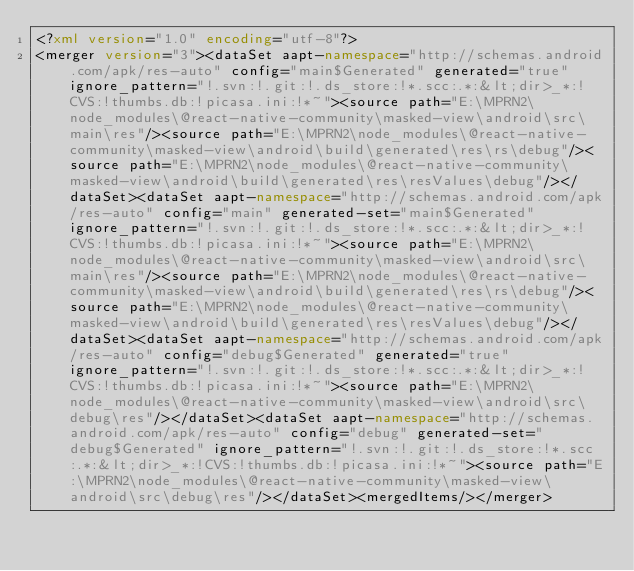<code> <loc_0><loc_0><loc_500><loc_500><_XML_><?xml version="1.0" encoding="utf-8"?>
<merger version="3"><dataSet aapt-namespace="http://schemas.android.com/apk/res-auto" config="main$Generated" generated="true" ignore_pattern="!.svn:!.git:!.ds_store:!*.scc:.*:&lt;dir>_*:!CVS:!thumbs.db:!picasa.ini:!*~"><source path="E:\MPRN2\node_modules\@react-native-community\masked-view\android\src\main\res"/><source path="E:\MPRN2\node_modules\@react-native-community\masked-view\android\build\generated\res\rs\debug"/><source path="E:\MPRN2\node_modules\@react-native-community\masked-view\android\build\generated\res\resValues\debug"/></dataSet><dataSet aapt-namespace="http://schemas.android.com/apk/res-auto" config="main" generated-set="main$Generated" ignore_pattern="!.svn:!.git:!.ds_store:!*.scc:.*:&lt;dir>_*:!CVS:!thumbs.db:!picasa.ini:!*~"><source path="E:\MPRN2\node_modules\@react-native-community\masked-view\android\src\main\res"/><source path="E:\MPRN2\node_modules\@react-native-community\masked-view\android\build\generated\res\rs\debug"/><source path="E:\MPRN2\node_modules\@react-native-community\masked-view\android\build\generated\res\resValues\debug"/></dataSet><dataSet aapt-namespace="http://schemas.android.com/apk/res-auto" config="debug$Generated" generated="true" ignore_pattern="!.svn:!.git:!.ds_store:!*.scc:.*:&lt;dir>_*:!CVS:!thumbs.db:!picasa.ini:!*~"><source path="E:\MPRN2\node_modules\@react-native-community\masked-view\android\src\debug\res"/></dataSet><dataSet aapt-namespace="http://schemas.android.com/apk/res-auto" config="debug" generated-set="debug$Generated" ignore_pattern="!.svn:!.git:!.ds_store:!*.scc:.*:&lt;dir>_*:!CVS:!thumbs.db:!picasa.ini:!*~"><source path="E:\MPRN2\node_modules\@react-native-community\masked-view\android\src\debug\res"/></dataSet><mergedItems/></merger></code> 